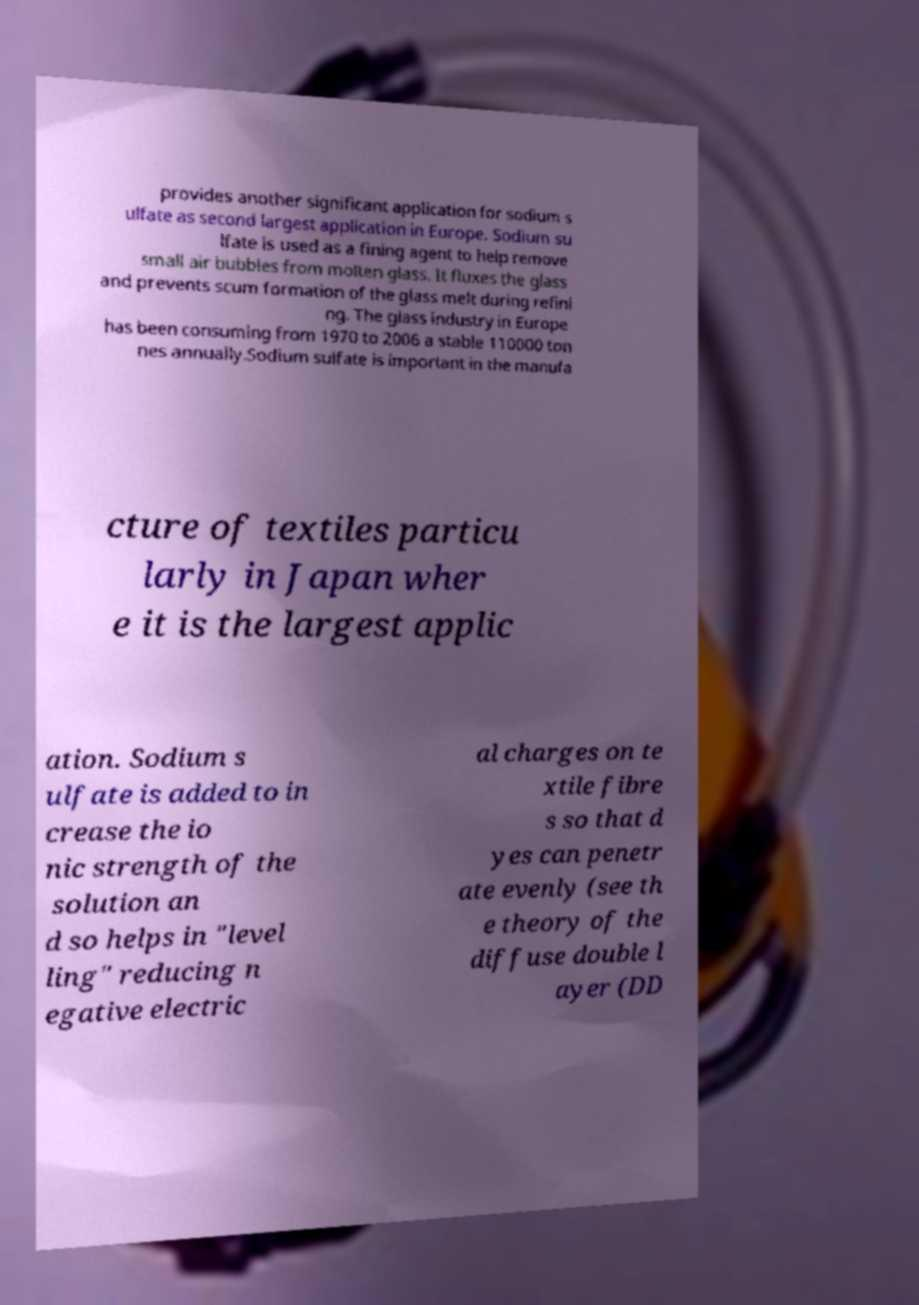I need the written content from this picture converted into text. Can you do that? provides another significant application for sodium s ulfate as second largest application in Europe. Sodium su lfate is used as a fining agent to help remove small air bubbles from molten glass. It fluxes the glass and prevents scum formation of the glass melt during refini ng. The glass industry in Europe has been consuming from 1970 to 2006 a stable 110000 ton nes annually.Sodium sulfate is important in the manufa cture of textiles particu larly in Japan wher e it is the largest applic ation. Sodium s ulfate is added to in crease the io nic strength of the solution an d so helps in "level ling" reducing n egative electric al charges on te xtile fibre s so that d yes can penetr ate evenly (see th e theory of the diffuse double l ayer (DD 